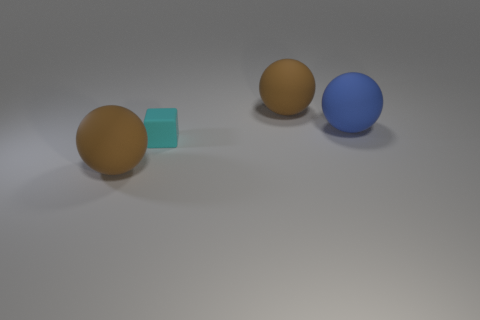Does the cyan object have the same material as the large brown object to the right of the tiny thing?
Your answer should be compact. Yes. What number of other objects are there of the same size as the blue matte sphere?
Give a very brief answer. 2. Are there any big things that are in front of the rubber ball that is on the right side of the large brown thing that is on the right side of the matte cube?
Ensure brevity in your answer.  Yes. The blue matte thing is what size?
Offer a very short reply. Large. There is a brown rubber ball in front of the blue matte sphere; what is its size?
Offer a very short reply. Large. There is a object that is in front of the cube; is it the same size as the tiny cyan rubber cube?
Provide a succinct answer. No. Are there any other things that have the same color as the small object?
Your response must be concise. No. What shape is the tiny rubber thing?
Make the answer very short. Cube. How many large objects are left of the blue object and behind the cyan rubber object?
Offer a very short reply. 1. Are there an equal number of big brown rubber things in front of the blue ball and matte things that are right of the cyan matte thing?
Offer a terse response. No. 